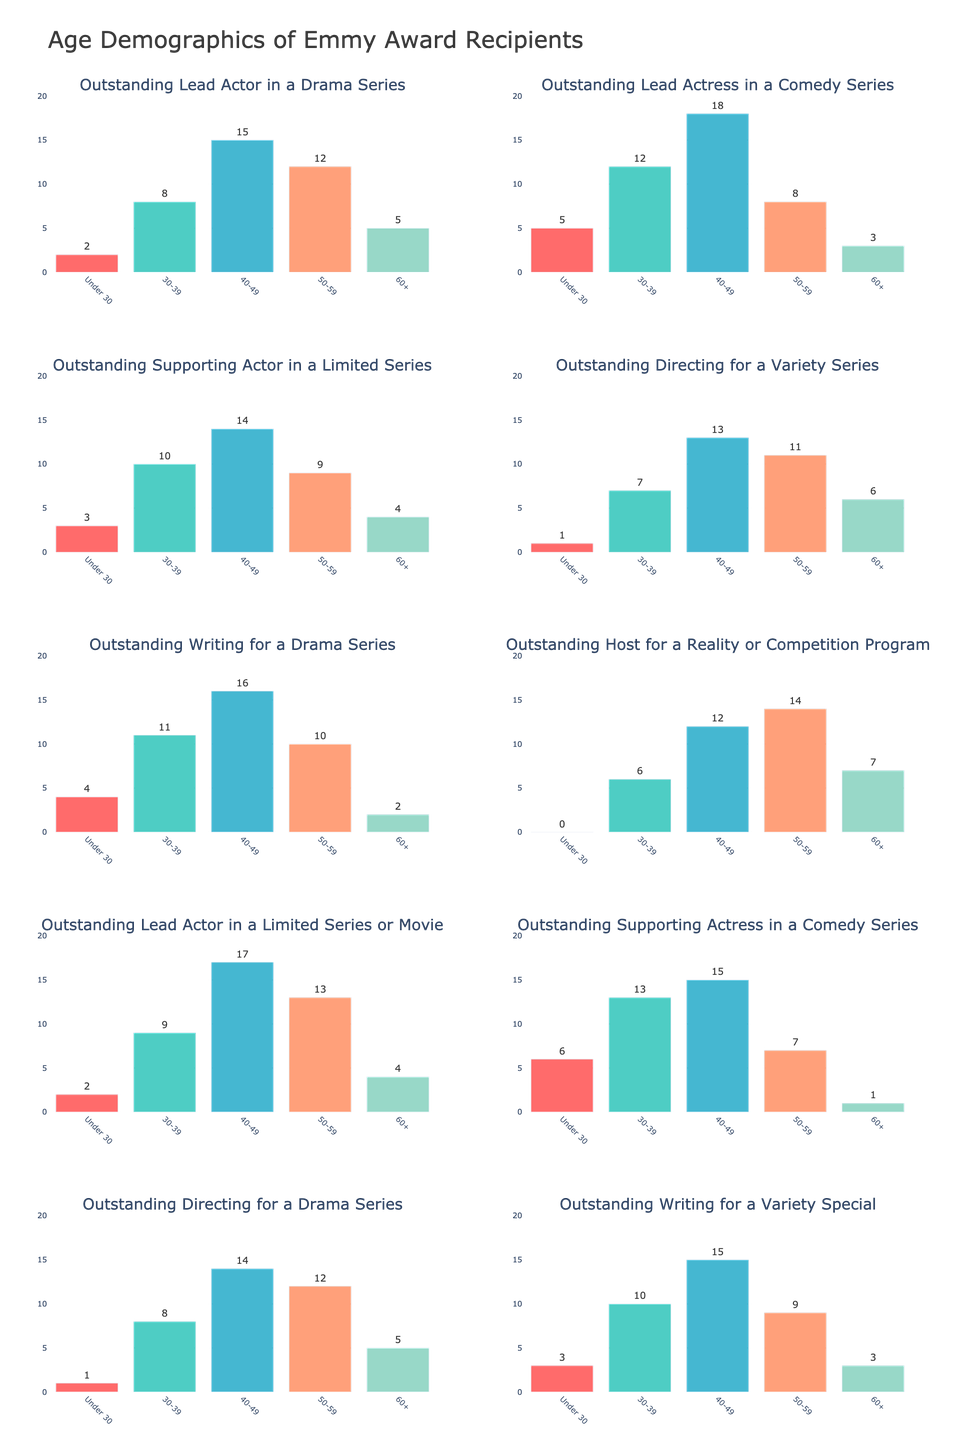How many total Emmy Award recipients are aged 50-59 across all categories? Sum the number of recipients aged 50-59 in each category: 12 (Drama Actor) + 8 (Comedy Actress) + 9 (Limited Series Actor) + 11 (Variety Director) + 10 (Drama Writer) + 14 (Reality Host) + 13 (Limited Movie Actor) + 7 (Comedy Actress) + 12 (Drama Director) + 9 (Variety Writer) = 105
Answer: 105 Which category has the highest number of recipients under 30? Compare the numbers under the "Under 30" column for each category: 2 (Drama Actor), 5 (Comedy Actress), 3 (Limited Series Actor), 1 (Variety Director), 4 (Drama Writer), 0 (Reality Host), 2 (Limited Movie Actor), 6 (Comedy Actress), 1 (Drama Director), 3 (Variety Writer). Comedy Actress in a Comedy Series has the highest number with 6 recipients
Answer: Outstanding Supporting Actress in a Comedy Series Which age group has the least number of recipients in the Outstanding Host for a Reality or Competition Program category? Check the values for each age group in the category: 0 (Under 30), 6 (30-39), 12 (40-49), 14 (50-59), 7 (60+). The age group Under 30 has the least number with 0 recipients
Answer: Under 30 Which categories have more recipients aged 40-49 compared to recipients aged 50-59? Compare the 40-49 and 50-59 numbers for each category: Outstanding Lead Actor in a Drama Series (15 vs 12), Outstanding Lead Actress in a Comedy Series (18 vs 8), Outstanding Supporting Actor in a Limited Series (14 vs 9), Outstanding Directing for a Variety Series (13 vs 11), Outstanding Writing for a Drama Series (16 vs 10), Outstanding Host for a Reality or Competition Program (12 vs 14), Outstanding Lead Actor in a Limited Series or Movie (17 vs 13), Outstanding Supporting Actress in a Comedy Series (15 vs 7), Outstanding Directing for a Drama Series (14 vs 12), Outstanding Writing for a Variety Special (15 vs 9). Categories with more recipients aged 40-49 compared to 50-59 are all except Outstanding Host for a Reality Program
Answer: 9 categories (all except the Reality Host category) For the category Outstanding Writing for a Drama Series, calculate the average number of recipients in the age groups: Under 30, 30-39, 40-49, 50-59, and 60+ Sum the recipients for the category and divide by number of groups: (4 + 11 + 16 + 10 + 2) / 5 = 43 / 5 = 8.6
Answer: 8.6 